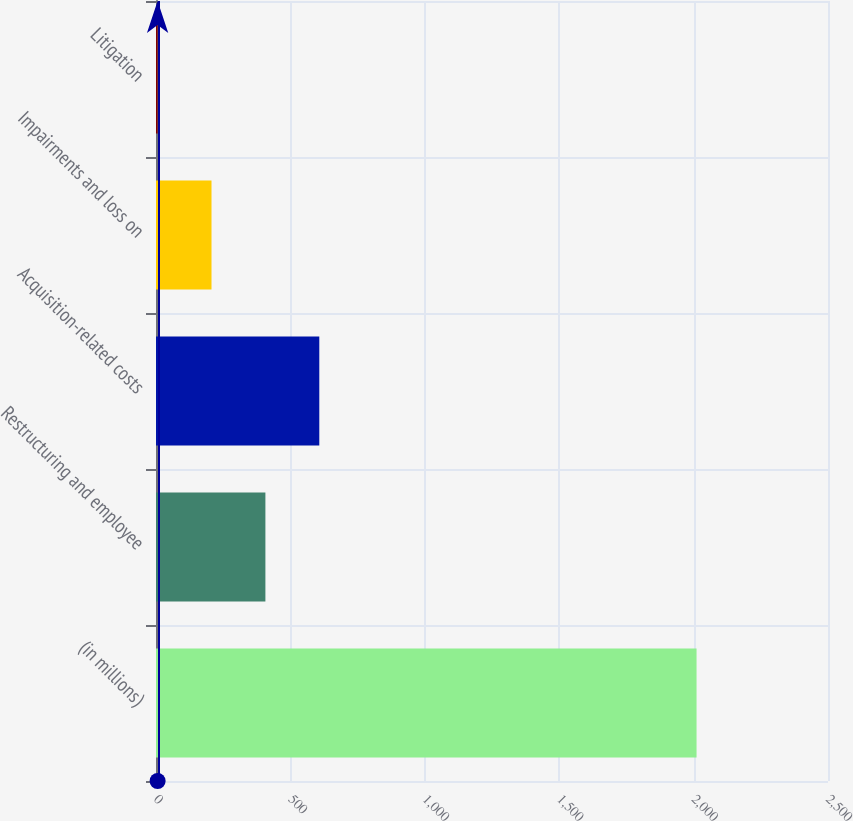<chart> <loc_0><loc_0><loc_500><loc_500><bar_chart><fcel>(in millions)<fcel>Restructuring and employee<fcel>Acquisition-related costs<fcel>Impairments and loss on<fcel>Litigation<nl><fcel>2011<fcel>407<fcel>607.5<fcel>206.5<fcel>6<nl></chart> 